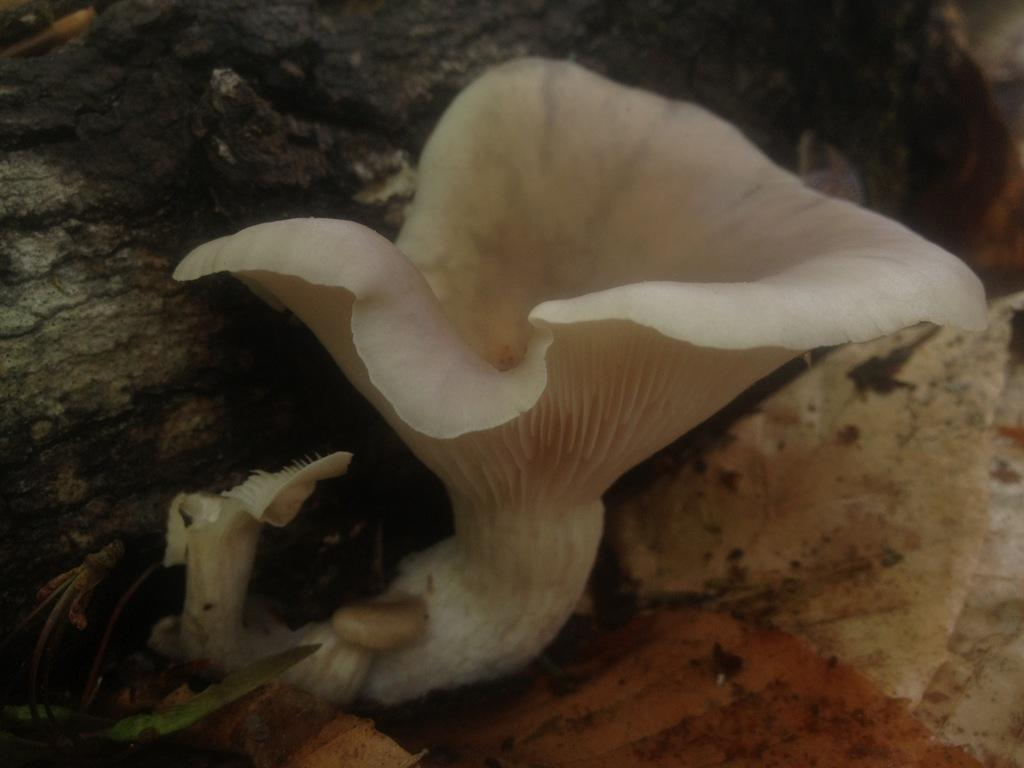What is the main subject of the image? The main subject of the image is a flower. Can you describe the background of the flower in the image? There is a rock behind the flower in the image. What type of spade can be seen in the image? There is no spade present in the image. What is the height of the flower in the image? The height of the flower cannot be determined from the image alone. What type of marble is used to decorate the flower in the image? There is no marble present in the image, as it features a flower and a rock. 